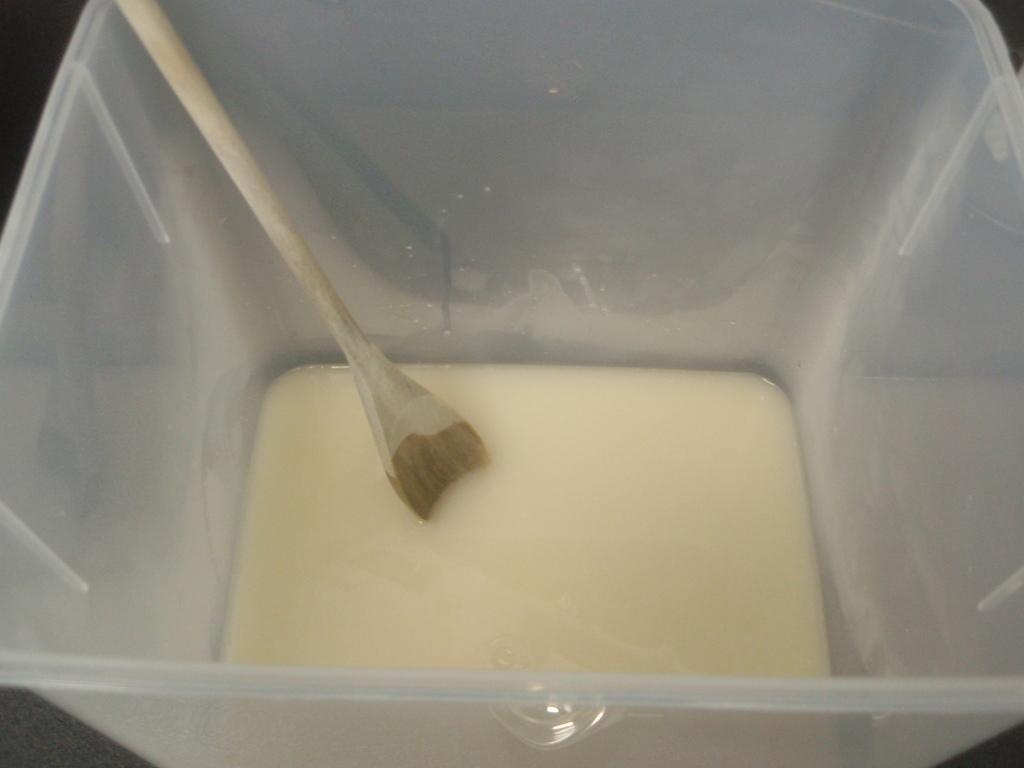What is the main substance visible in the image? There is a liquid in the image. What utensil is present in the image? There is a spoon in the image. Where is the spoon located in the image? The spoon is placed in a plastic box. What type of detail can be seen on the spoon in the image? There is no specific detail visible on the spoon in the image; it is a plain spoon placed in a plastic box. 